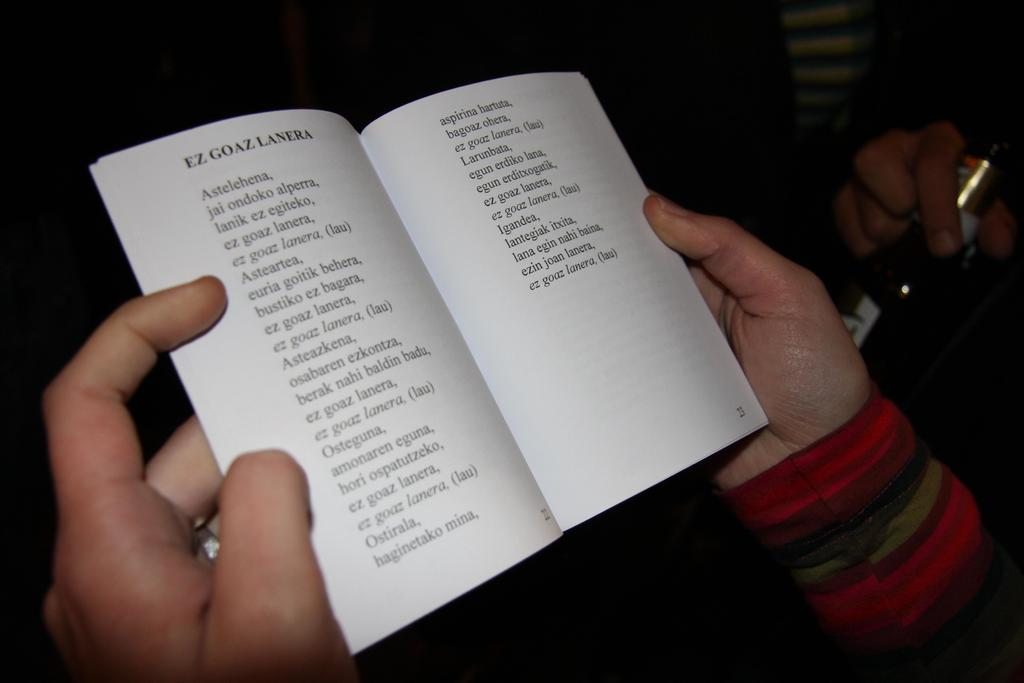<image>
Summarize the visual content of the image. Two hands hold open a small book on page 23. 